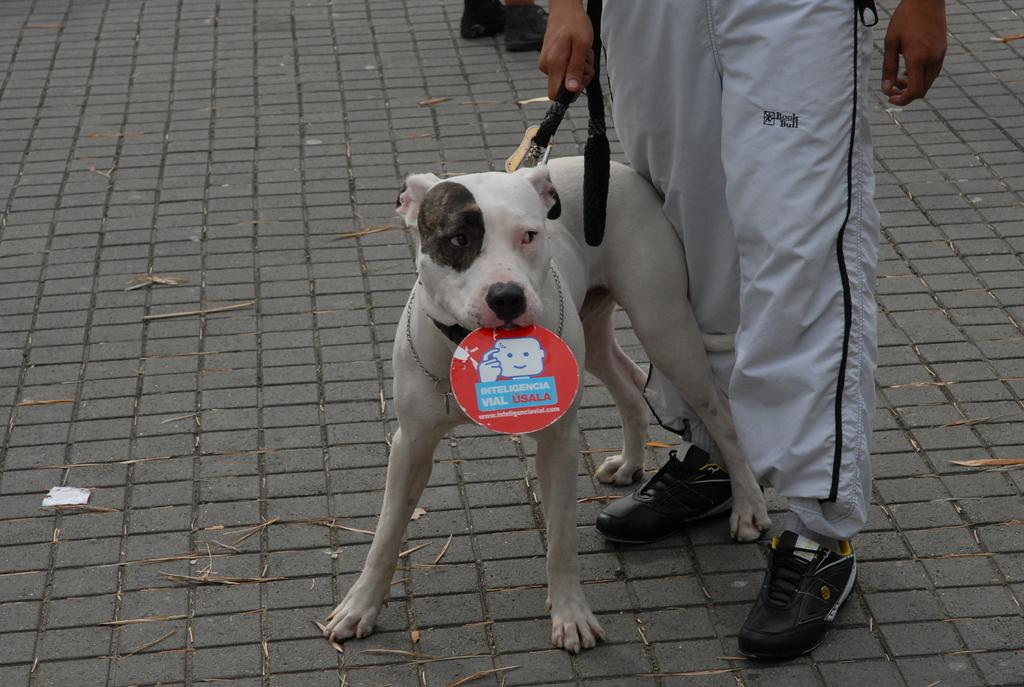What is the person in the image doing? The person is holding a dog in the image. What type of clothing is the person wearing? The person is wearing black shoes and track pants. What color is the dog being held by the person? The dog is white in color. What is the dog doing in the image? The dog is holding something in its mouth. Can you tell me how many windows are visible in the image? There are no windows visible in the image; it features a person holding a dog. What type of shock is the person experiencing in the image? There is no indication of any shock or surprise in the image; the person is simply holding a dog. 